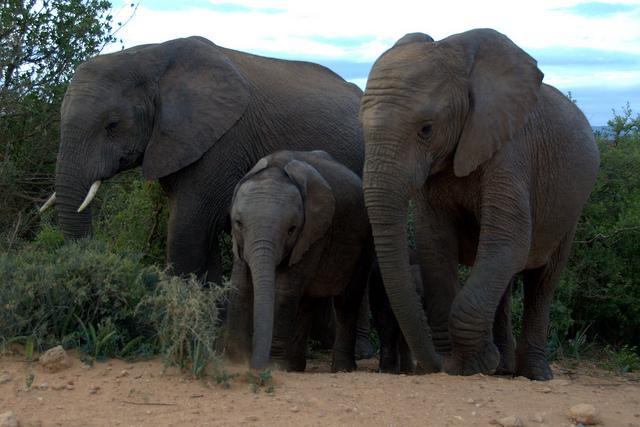What is the baby elephant called? calf 